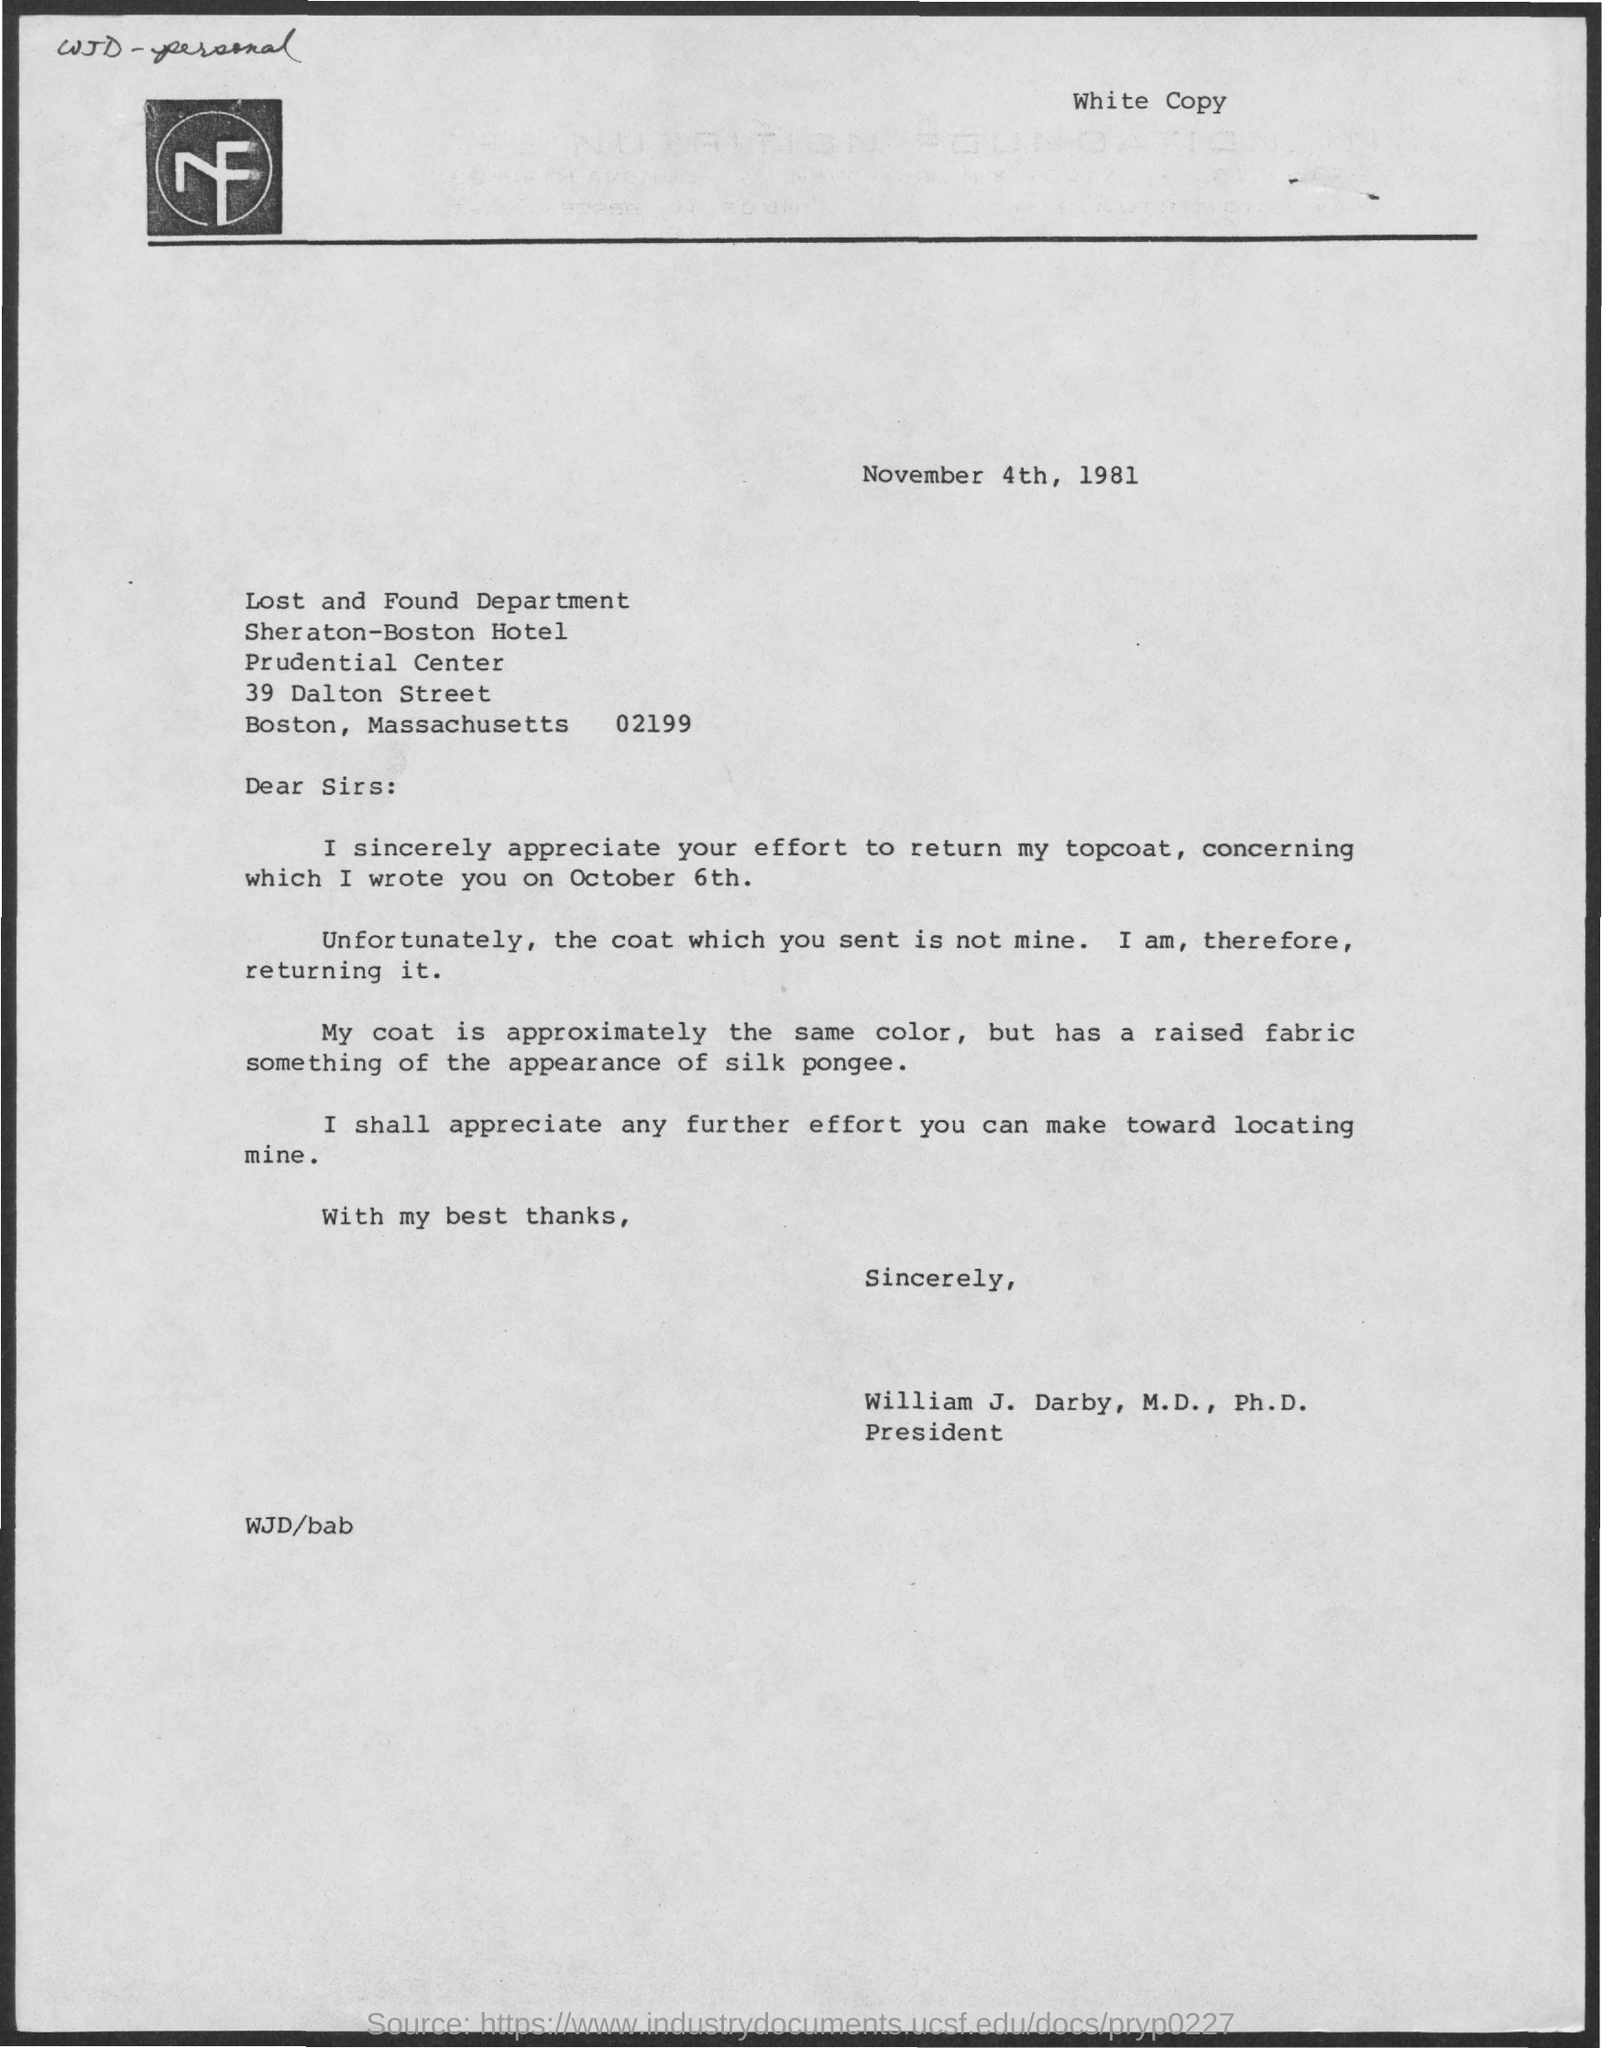What is the name of the department
Keep it short and to the point. Lost and found department. 